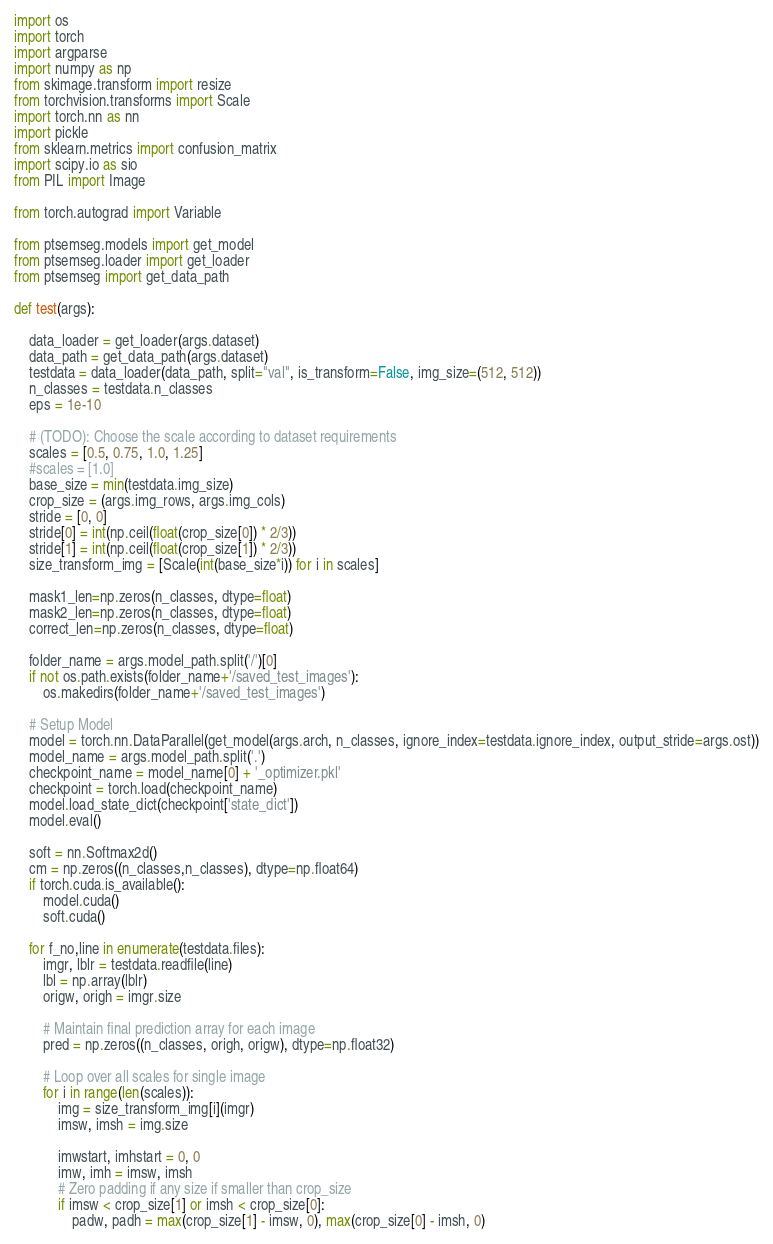Convert code to text. <code><loc_0><loc_0><loc_500><loc_500><_Python_>import os
import torch
import argparse
import numpy as np
from skimage.transform import resize
from torchvision.transforms import Scale
import torch.nn as nn
import pickle
from sklearn.metrics import confusion_matrix
import scipy.io as sio
from PIL import Image

from torch.autograd import Variable

from ptsemseg.models import get_model
from ptsemseg.loader import get_loader
from ptsemseg import get_data_path

def test(args):

    data_loader = get_loader(args.dataset)
    data_path = get_data_path(args.dataset)
    testdata = data_loader(data_path, split="val", is_transform=False, img_size=(512, 512))
    n_classes = testdata.n_classes
    eps = 1e-10

    # (TODO): Choose the scale according to dataset requirements
    scales = [0.5, 0.75, 1.0, 1.25]
    #scales = [1.0]
    base_size = min(testdata.img_size)
    crop_size = (args.img_rows, args.img_cols)
    stride = [0, 0]
    stride[0] = int(np.ceil(float(crop_size[0]) * 2/3))
    stride[1] = int(np.ceil(float(crop_size[1]) * 2/3))
    size_transform_img = [Scale(int(base_size*i)) for i in scales]

    mask1_len=np.zeros(n_classes, dtype=float)
    mask2_len=np.zeros(n_classes, dtype=float)
    correct_len=np.zeros(n_classes, dtype=float)

    folder_name = args.model_path.split('/')[0]
    if not os.path.exists(folder_name+'/saved_test_images'):
        os.makedirs(folder_name+'/saved_test_images')

    # Setup Model
    model = torch.nn.DataParallel(get_model(args.arch, n_classes, ignore_index=testdata.ignore_index, output_stride=args.ost))
    model_name = args.model_path.split('.')
    checkpoint_name = model_name[0] + '_optimizer.pkl'
    checkpoint = torch.load(checkpoint_name)
    model.load_state_dict(checkpoint['state_dict'])
    model.eval()

    soft = nn.Softmax2d()
    cm = np.zeros((n_classes,n_classes), dtype=np.float64)
    if torch.cuda.is_available():
        model.cuda()
        soft.cuda()

    for f_no,line in enumerate(testdata.files):
        imgr, lblr = testdata.readfile(line)
        lbl = np.array(lblr)
        origw, origh = imgr.size

        # Maintain final prediction array for each image
        pred = np.zeros((n_classes, origh, origw), dtype=np.float32)

        # Loop over all scales for single image
        for i in range(len(scales)):
            img = size_transform_img[i](imgr)
            imsw, imsh = img.size

            imwstart, imhstart = 0, 0
            imw, imh = imsw, imsh
            # Zero padding if any size if smaller than crop_size
            if imsw < crop_size[1] or imsh < crop_size[0]:
                padw, padh = max(crop_size[1] - imsw, 0), max(crop_size[0] - imsh, 0)</code> 